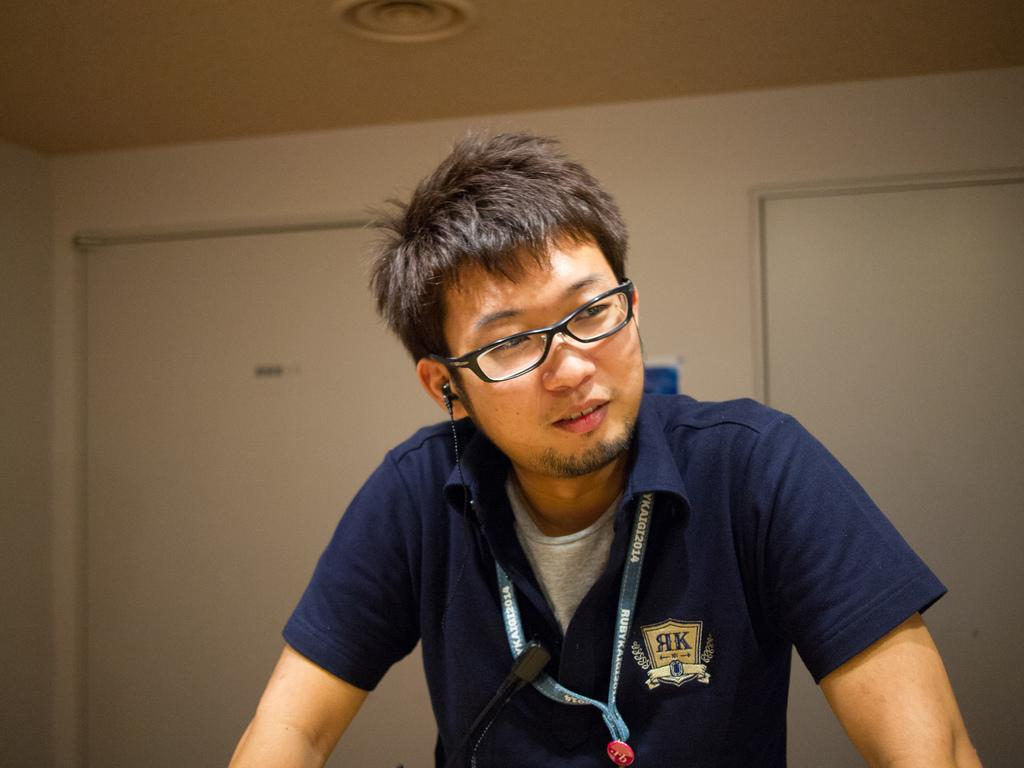Who or what is in the image? There is a person in the image. What object is in front of the person? There is a microphone (mike) in front of the person. What is behind the person? There is a wall behind the person. What can be seen at the top of the image? There is a light visible at the top of the image. What type of curve can be seen in the person's hair in the image? There is no curve visible in the person's hair in the image. What flavor of eggnog is being served at the event in the image? There is no event or eggnog present in the image. 